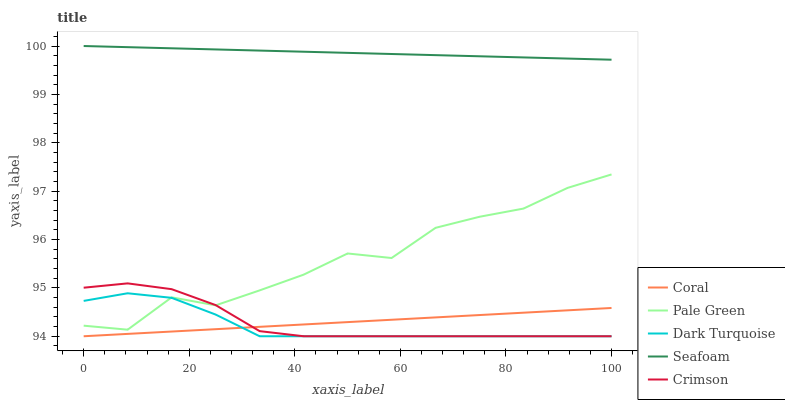Does Dark Turquoise have the minimum area under the curve?
Answer yes or no. Yes. Does Seafoam have the maximum area under the curve?
Answer yes or no. Yes. Does Coral have the minimum area under the curve?
Answer yes or no. No. Does Coral have the maximum area under the curve?
Answer yes or no. No. Is Coral the smoothest?
Answer yes or no. Yes. Is Pale Green the roughest?
Answer yes or no. Yes. Is Dark Turquoise the smoothest?
Answer yes or no. No. Is Dark Turquoise the roughest?
Answer yes or no. No. Does Pale Green have the lowest value?
Answer yes or no. No. Does Seafoam have the highest value?
Answer yes or no. Yes. Does Dark Turquoise have the highest value?
Answer yes or no. No. Is Dark Turquoise less than Seafoam?
Answer yes or no. Yes. Is Seafoam greater than Crimson?
Answer yes or no. Yes. Does Crimson intersect Coral?
Answer yes or no. Yes. Is Crimson less than Coral?
Answer yes or no. No. Is Crimson greater than Coral?
Answer yes or no. No. Does Dark Turquoise intersect Seafoam?
Answer yes or no. No. 